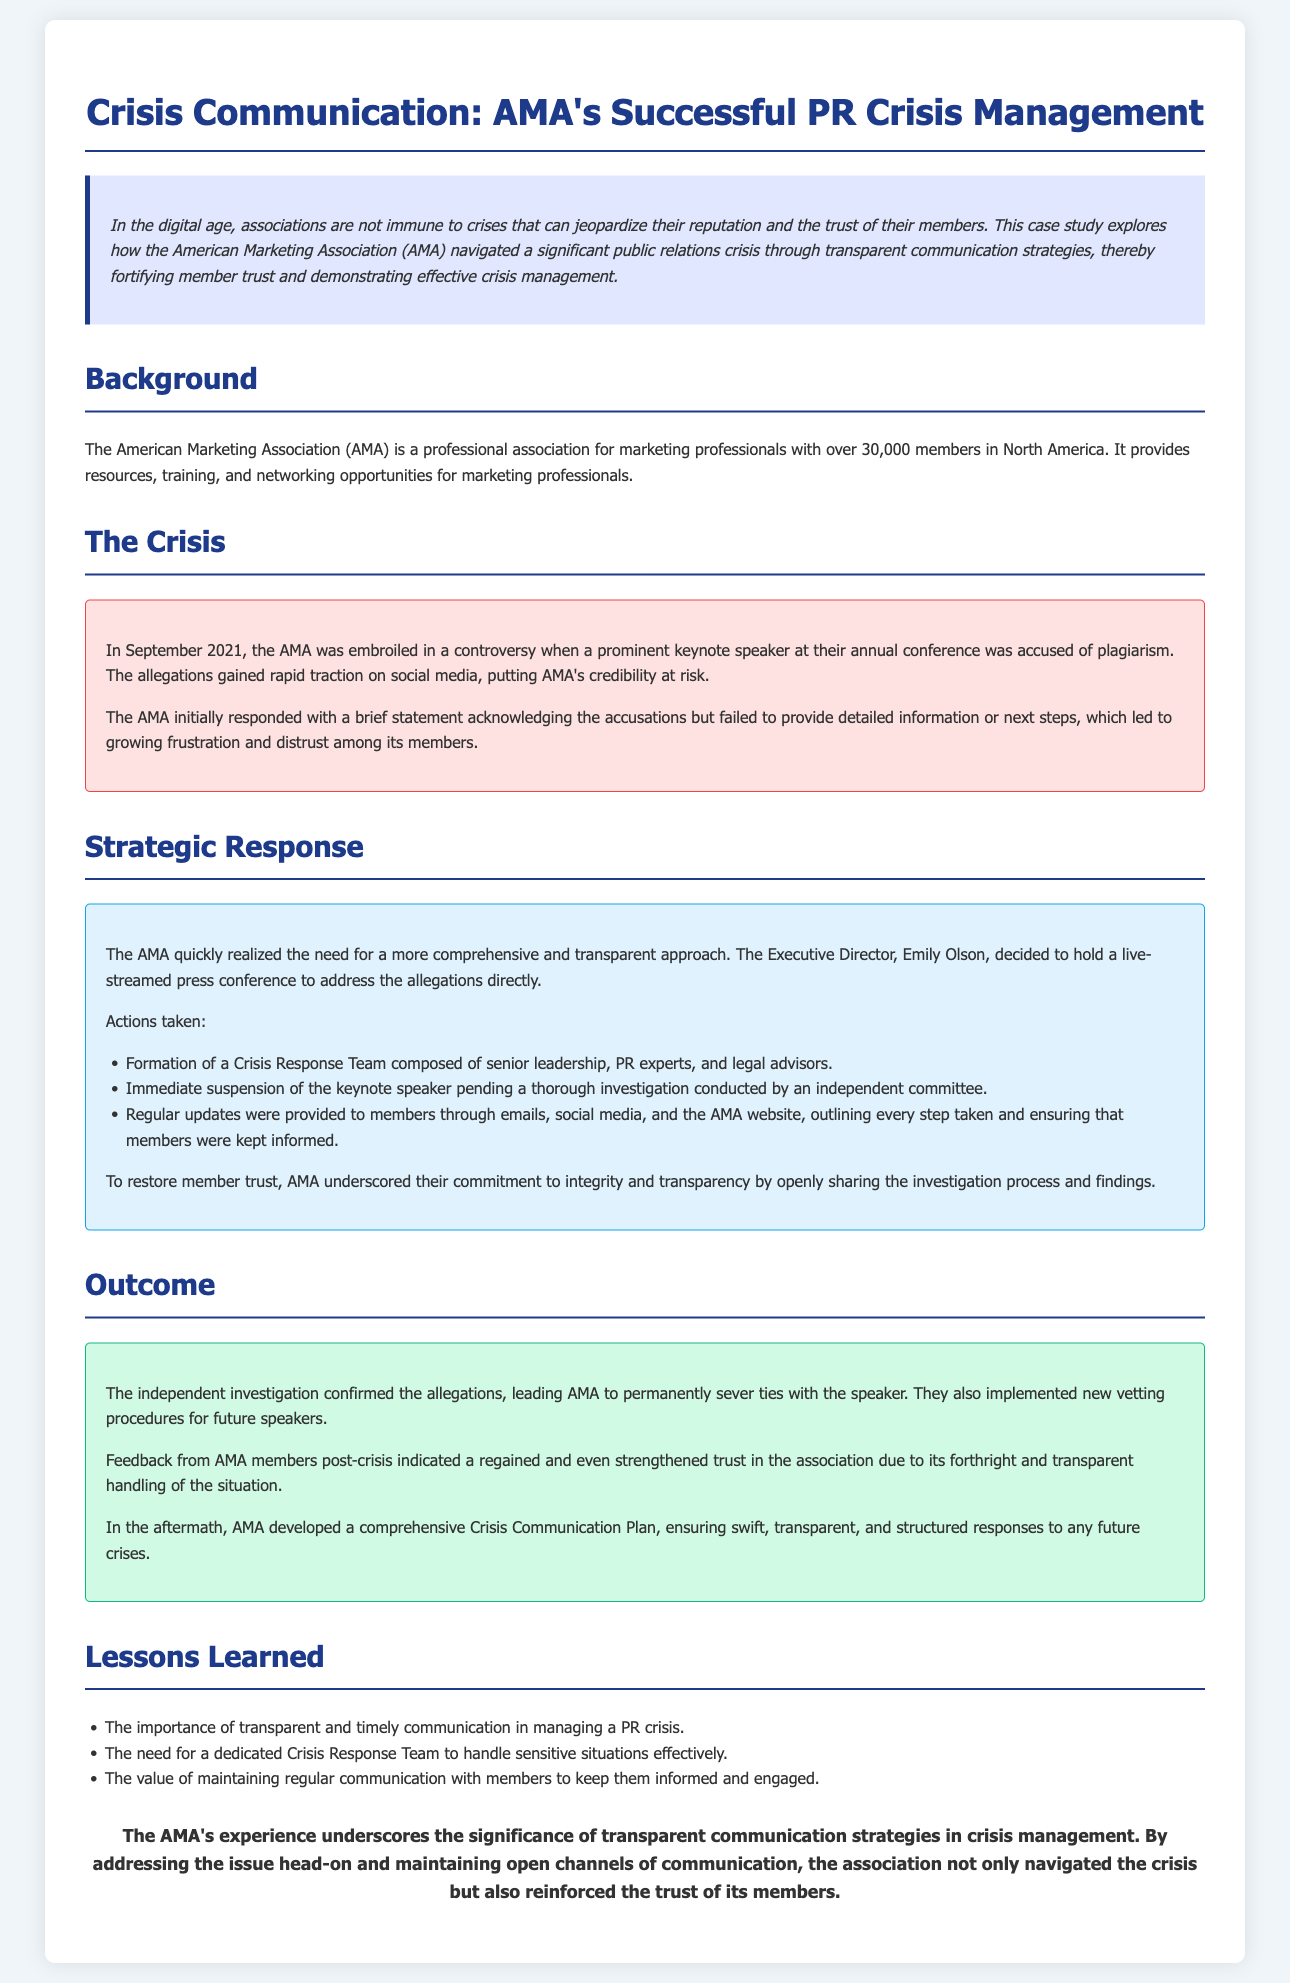What was the controversy involving AMA in September 2021? The controversy involved a prominent keynote speaker accused of plagiarism.
Answer: Plagiarism Who is the Executive Director of AMA? Emily Olson is named as the Executive Director in the document.
Answer: Emily Olson What comprised the Crisis Response Team? The Crisis Response Team consisted of senior leadership, PR experts, and legal advisors.
Answer: Senior leadership, PR experts, and legal advisors What method did AMA use to address the allegations? AMA held a live-streamed press conference to address the allegations directly.
Answer: Live-streamed press conference What did the independent investigation confirm? The investigation confirmed the allegations against the keynote speaker.
Answer: Confirmed the allegations What new procedures did AMA implement post-crisis? AMA implemented new vetting procedures for future speakers.
Answer: New vetting procedures How many members does AMA have in North America? The AMA has over 30,000 members in North America.
Answer: Over 30,000 What did AMA do to communicate with members during the crisis? AMA provided regular updates through emails, social media, and the AMA website.
Answer: Regular updates through emails, social media, and the AMA website What trend was observed in member trust after the crisis? Feedback indicated a regained and even strengthened trust in the association.
Answer: Strengthened trust 